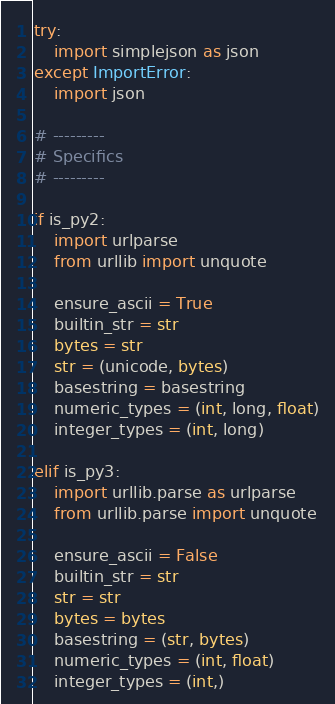Convert code to text. <code><loc_0><loc_0><loc_500><loc_500><_Python_>
try:
    import simplejson as json
except ImportError:
    import json

# ---------
# Specifics
# ---------

if is_py2:
    import urlparse
    from urllib import unquote

    ensure_ascii = True
    builtin_str = str
    bytes = str
    str = (unicode, bytes)
    basestring = basestring
    numeric_types = (int, long, float)
    integer_types = (int, long)

elif is_py3:
    import urllib.parse as urlparse
    from urllib.parse import unquote

    ensure_ascii = False
    builtin_str = str
    str = str
    bytes = bytes
    basestring = (str, bytes)
    numeric_types = (int, float)
    integer_types = (int,)
</code> 